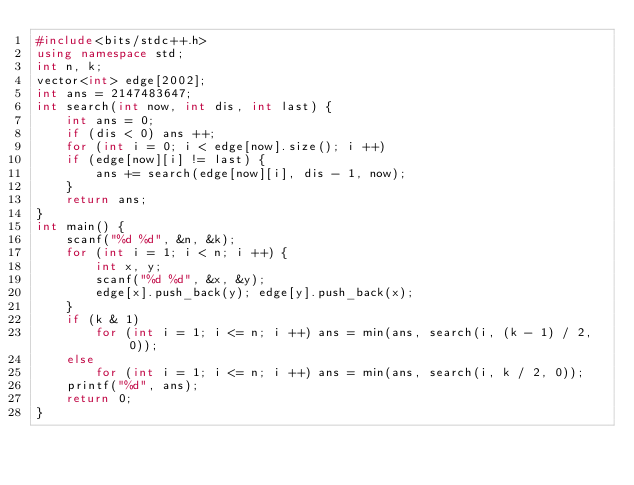Convert code to text. <code><loc_0><loc_0><loc_500><loc_500><_C++_>#include<bits/stdc++.h>
using namespace std;
int n, k;
vector<int> edge[2002];
int ans = 2147483647;
int search(int now, int dis, int last) {
    int ans = 0;
    if (dis < 0) ans ++;
    for (int i = 0; i < edge[now].size(); i ++)
    if (edge[now][i] != last) {
        ans += search(edge[now][i], dis - 1, now);
    }
    return ans;
}
int main() {
    scanf("%d %d", &n, &k);
    for (int i = 1; i < n; i ++) {
        int x, y;
        scanf("%d %d", &x, &y);
        edge[x].push_back(y); edge[y].push_back(x);
    }
    if (k & 1)
        for (int i = 1; i <= n; i ++) ans = min(ans, search(i, (k - 1) / 2, 0));
    else
        for (int i = 1; i <= n; i ++) ans = min(ans, search(i, k / 2, 0));
    printf("%d", ans);
    return 0;
}
</code> 